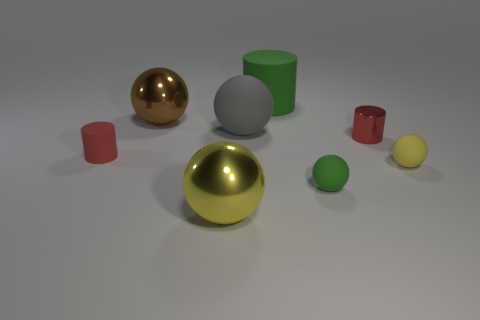Subtract all blue balls. How many red cylinders are left? 2 Subtract all brown balls. How many balls are left? 4 Subtract all tiny yellow rubber balls. How many balls are left? 4 Add 1 green matte cylinders. How many objects exist? 9 Subtract all red balls. Subtract all brown blocks. How many balls are left? 5 Subtract all cylinders. How many objects are left? 5 Add 8 small red metallic cylinders. How many small red metallic cylinders exist? 9 Subtract 0 blue spheres. How many objects are left? 8 Subtract all small red matte spheres. Subtract all brown things. How many objects are left? 7 Add 2 tiny things. How many tiny things are left? 6 